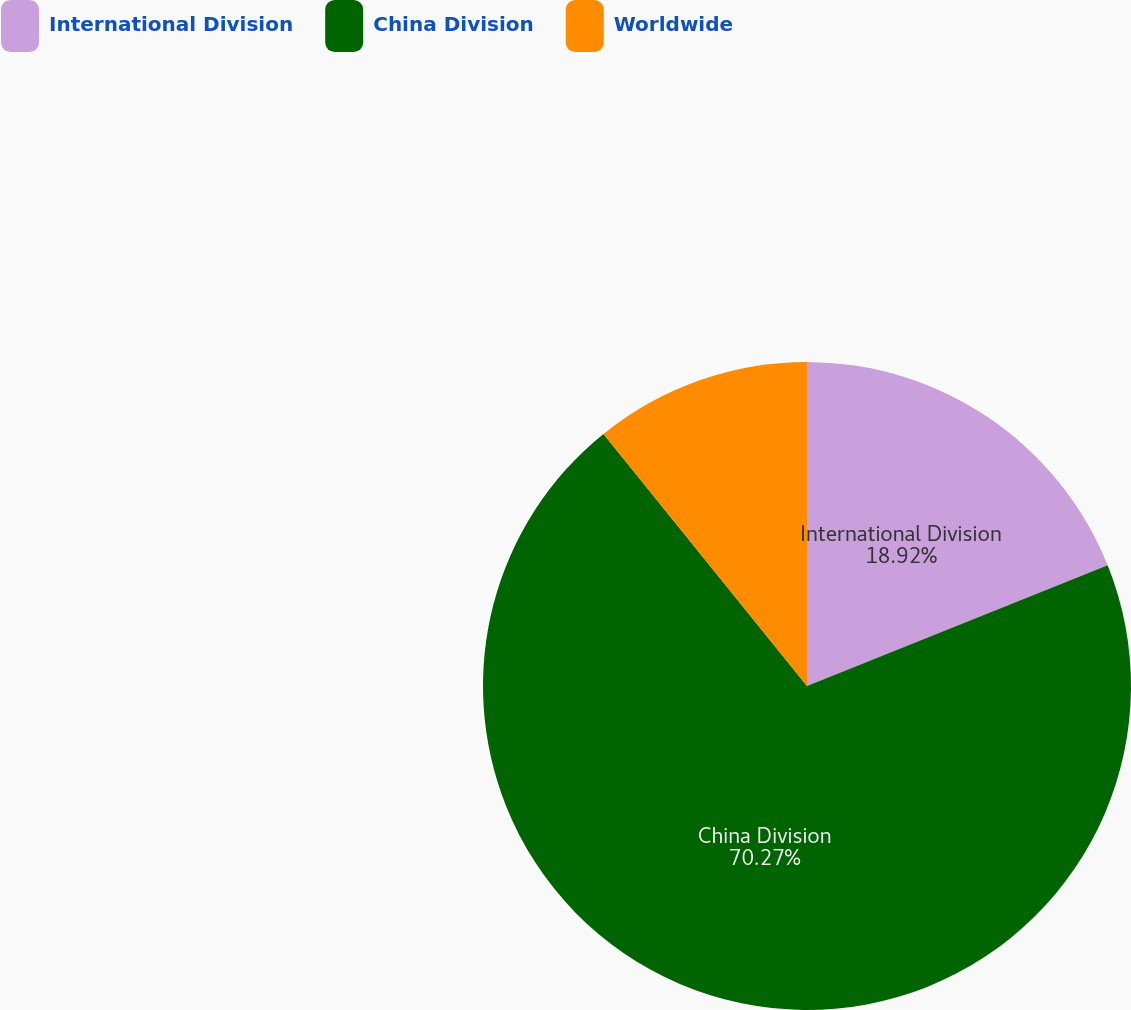<chart> <loc_0><loc_0><loc_500><loc_500><pie_chart><fcel>International Division<fcel>China Division<fcel>Worldwide<nl><fcel>18.92%<fcel>70.27%<fcel>10.81%<nl></chart> 